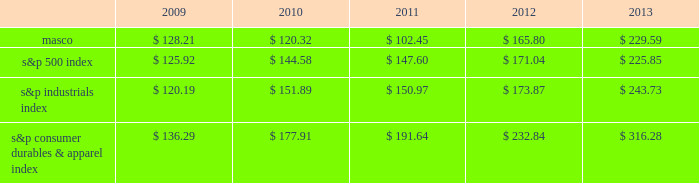6feb201418202649 performance graph the table below compares the cumulative total shareholder return on our common stock with the cumulative total return of ( i ) the standard & poor 2019s 500 composite stock index ( 2018 2018s&p 500 index 2019 2019 ) , ( ii ) the standard & poor 2019s industrials index ( 2018 2018s&p industrials index 2019 2019 ) and ( iii ) the standard & poor 2019s consumer durables & apparel index ( 2018 2018s&p consumer durables & apparel index 2019 2019 ) , from december 31 , 2008 through december 31 , 2013 , when the closing price of our common stock was $ 22.77 .
The graph assumes investments of $ 100 on december 31 , 2008 in our common stock and in each of the three indices and the reinvestment of dividends .
$ 350.00 $ 300.00 $ 250.00 $ 200.00 $ 150.00 $ 100.00 $ 50.00 performance graph .
In july 2007 , our board of directors authorized the purchase of up to 50 million shares of our common stock in open-market transactions or otherwise .
At december 31 , 2013 , we had remaining authorization to repurchase up to 22.6 million shares .
During the first quarter of 2013 , we repurchased and retired 1.7 million shares of our common stock , for cash aggregating $ 35 million to offset the dilutive impact of the 2013 grant of 1.7 million shares of long-term stock awards .
We have not purchased any shares since march 2013. .
What was the percent of the increase in the performance of s&p 500 index from 2009 to 2010? 
Rationale: the performance of s&p 500 index increased by 14.92% from 2009 to 2010
Computations: ((144.58 / 125.92) / 125.92)
Answer: 0.00912. 